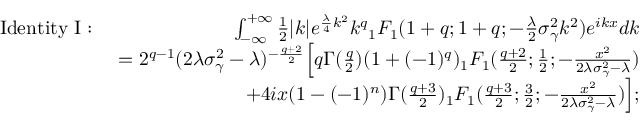<formula> <loc_0><loc_0><loc_500><loc_500>\begin{array} { r l r } & { I d e n t i t y \ I \colon \ } & { \int _ { - \infty } ^ { + \infty } \frac { 1 } { 2 } | k | e ^ { \frac { \lambda } { 4 } k ^ { 2 } } k ^ { q } { _ { 1 } F _ { 1 } } ( 1 + q ; 1 + q ; - \frac { \lambda } { 2 } \sigma _ { \gamma } ^ { 2 } k ^ { 2 } ) e ^ { i k x } d k } \\ & { = 2 ^ { q - 1 } ( 2 \lambda \sigma _ { \gamma } ^ { 2 } - \lambda ) ^ { - \frac { q + 2 } { 2 } } \left [ q \Gamma ( \frac { q } { 2 } ) ( 1 + ( - 1 ) ^ { q } ) { _ { 1 } F _ { 1 } } ( \frac { q + 2 } { 2 } ; \frac { 1 } { 2 } ; - \frac { x ^ { 2 } } { 2 \lambda \sigma _ { \gamma } ^ { 2 } - \lambda } ) } \\ & { + 4 i x ( 1 - ( - 1 ) ^ { n } ) \Gamma ( \frac { q + 3 } { 2 } ) { _ { 1 } F _ { 1 } } ( \frac { q + 3 } { 2 } ; \frac { 3 } { 2 } ; - \frac { x ^ { 2 } } { 2 \lambda \sigma _ { \gamma } ^ { 2 } - \lambda } ) \right ] ; } \end{array}</formula> 